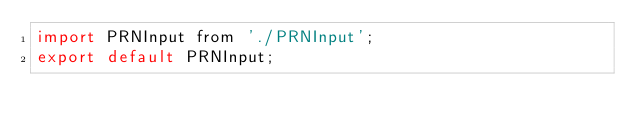<code> <loc_0><loc_0><loc_500><loc_500><_JavaScript_>import PRNInput from './PRNInput';
export default PRNInput;
</code> 